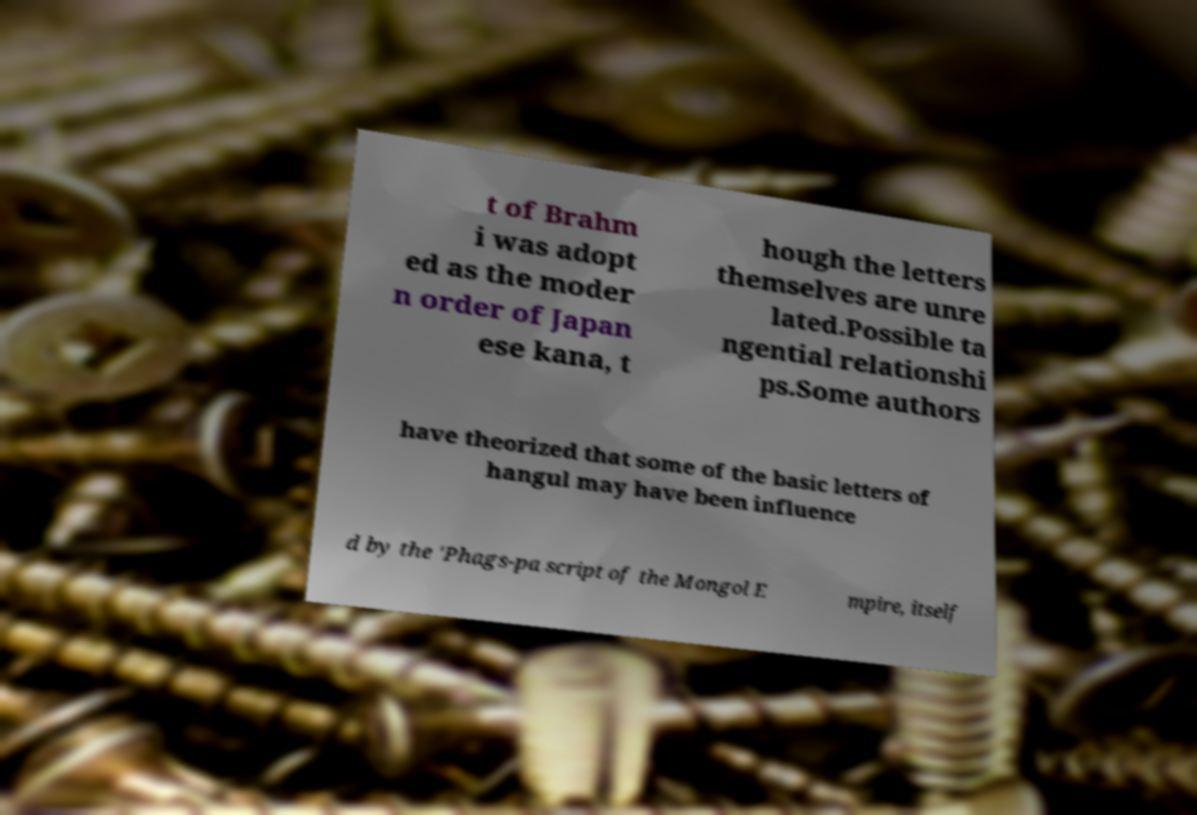What messages or text are displayed in this image? I need them in a readable, typed format. t of Brahm i was adopt ed as the moder n order of Japan ese kana, t hough the letters themselves are unre lated.Possible ta ngential relationshi ps.Some authors have theorized that some of the basic letters of hangul may have been influence d by the 'Phags-pa script of the Mongol E mpire, itself 